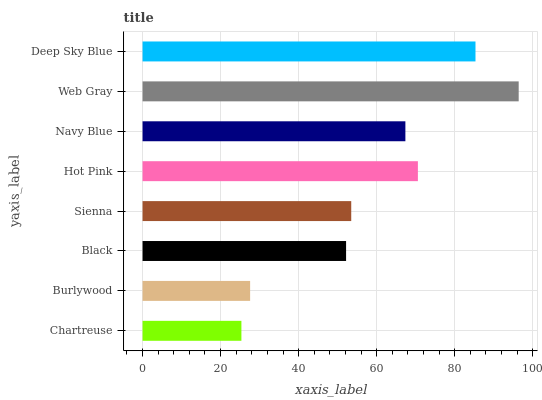Is Chartreuse the minimum?
Answer yes or no. Yes. Is Web Gray the maximum?
Answer yes or no. Yes. Is Burlywood the minimum?
Answer yes or no. No. Is Burlywood the maximum?
Answer yes or no. No. Is Burlywood greater than Chartreuse?
Answer yes or no. Yes. Is Chartreuse less than Burlywood?
Answer yes or no. Yes. Is Chartreuse greater than Burlywood?
Answer yes or no. No. Is Burlywood less than Chartreuse?
Answer yes or no. No. Is Navy Blue the high median?
Answer yes or no. Yes. Is Sienna the low median?
Answer yes or no. Yes. Is Sienna the high median?
Answer yes or no. No. Is Burlywood the low median?
Answer yes or no. No. 